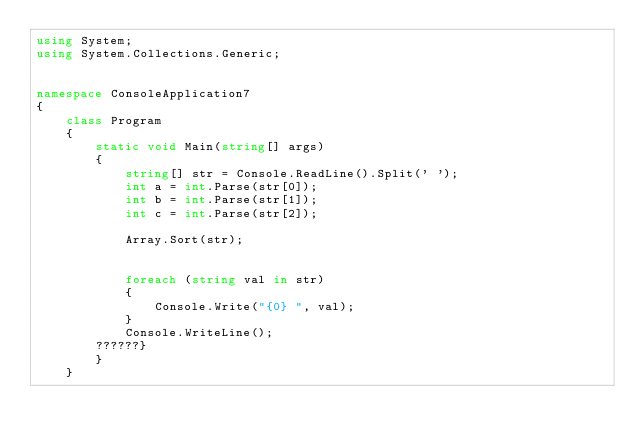Convert code to text. <code><loc_0><loc_0><loc_500><loc_500><_C#_>using System;
using System.Collections.Generic;


namespace ConsoleApplication7
{
    class Program
    {
        static void Main(string[] args)
        {
            string[] str = Console.ReadLine().Split(' ');
            int a = int.Parse(str[0]);
            int b = int.Parse(str[1]);
            int c = int.Parse(str[2]);

            Array.Sort(str);

   
            foreach (string val in str)
            {
                Console.Write("{0} ", val);
            }
            Console.WriteLine();
        ??????}
        }
    }</code> 